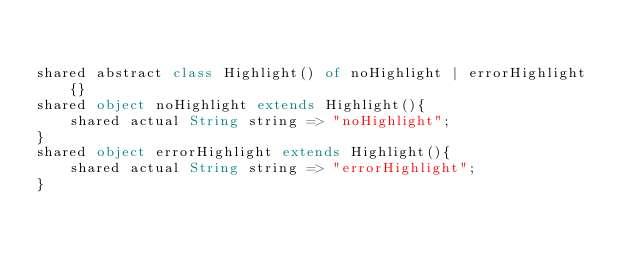Convert code to text. <code><loc_0><loc_0><loc_500><loc_500><_Ceylon_>

shared abstract class Highlight() of noHighlight | errorHighlight {}
shared object noHighlight extends Highlight(){
    shared actual String string => "noHighlight";
}
shared object errorHighlight extends Highlight(){
    shared actual String string => "errorHighlight";
}
</code> 